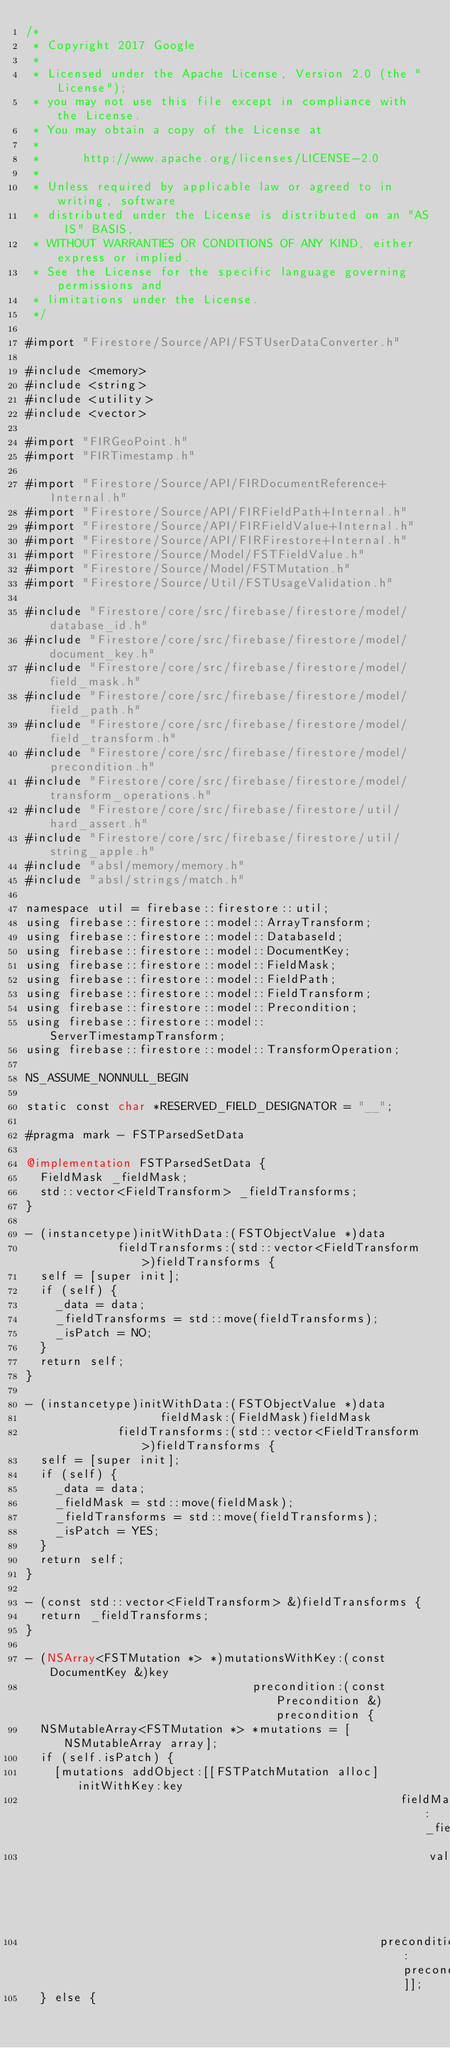Convert code to text. <code><loc_0><loc_0><loc_500><loc_500><_ObjectiveC_>/*
 * Copyright 2017 Google
 *
 * Licensed under the Apache License, Version 2.0 (the "License");
 * you may not use this file except in compliance with the License.
 * You may obtain a copy of the License at
 *
 *      http://www.apache.org/licenses/LICENSE-2.0
 *
 * Unless required by applicable law or agreed to in writing, software
 * distributed under the License is distributed on an "AS IS" BASIS,
 * WITHOUT WARRANTIES OR CONDITIONS OF ANY KIND, either express or implied.
 * See the License for the specific language governing permissions and
 * limitations under the License.
 */

#import "Firestore/Source/API/FSTUserDataConverter.h"

#include <memory>
#include <string>
#include <utility>
#include <vector>

#import "FIRGeoPoint.h"
#import "FIRTimestamp.h"

#import "Firestore/Source/API/FIRDocumentReference+Internal.h"
#import "Firestore/Source/API/FIRFieldPath+Internal.h"
#import "Firestore/Source/API/FIRFieldValue+Internal.h"
#import "Firestore/Source/API/FIRFirestore+Internal.h"
#import "Firestore/Source/Model/FSTFieldValue.h"
#import "Firestore/Source/Model/FSTMutation.h"
#import "Firestore/Source/Util/FSTUsageValidation.h"

#include "Firestore/core/src/firebase/firestore/model/database_id.h"
#include "Firestore/core/src/firebase/firestore/model/document_key.h"
#include "Firestore/core/src/firebase/firestore/model/field_mask.h"
#include "Firestore/core/src/firebase/firestore/model/field_path.h"
#include "Firestore/core/src/firebase/firestore/model/field_transform.h"
#include "Firestore/core/src/firebase/firestore/model/precondition.h"
#include "Firestore/core/src/firebase/firestore/model/transform_operations.h"
#include "Firestore/core/src/firebase/firestore/util/hard_assert.h"
#include "Firestore/core/src/firebase/firestore/util/string_apple.h"
#include "absl/memory/memory.h"
#include "absl/strings/match.h"

namespace util = firebase::firestore::util;
using firebase::firestore::model::ArrayTransform;
using firebase::firestore::model::DatabaseId;
using firebase::firestore::model::DocumentKey;
using firebase::firestore::model::FieldMask;
using firebase::firestore::model::FieldPath;
using firebase::firestore::model::FieldTransform;
using firebase::firestore::model::Precondition;
using firebase::firestore::model::ServerTimestampTransform;
using firebase::firestore::model::TransformOperation;

NS_ASSUME_NONNULL_BEGIN

static const char *RESERVED_FIELD_DESIGNATOR = "__";

#pragma mark - FSTParsedSetData

@implementation FSTParsedSetData {
  FieldMask _fieldMask;
  std::vector<FieldTransform> _fieldTransforms;
}

- (instancetype)initWithData:(FSTObjectValue *)data
             fieldTransforms:(std::vector<FieldTransform>)fieldTransforms {
  self = [super init];
  if (self) {
    _data = data;
    _fieldTransforms = std::move(fieldTransforms);
    _isPatch = NO;
  }
  return self;
}

- (instancetype)initWithData:(FSTObjectValue *)data
                   fieldMask:(FieldMask)fieldMask
             fieldTransforms:(std::vector<FieldTransform>)fieldTransforms {
  self = [super init];
  if (self) {
    _data = data;
    _fieldMask = std::move(fieldMask);
    _fieldTransforms = std::move(fieldTransforms);
    _isPatch = YES;
  }
  return self;
}

- (const std::vector<FieldTransform> &)fieldTransforms {
  return _fieldTransforms;
}

- (NSArray<FSTMutation *> *)mutationsWithKey:(const DocumentKey &)key
                                precondition:(const Precondition &)precondition {
  NSMutableArray<FSTMutation *> *mutations = [NSMutableArray array];
  if (self.isPatch) {
    [mutations addObject:[[FSTPatchMutation alloc] initWithKey:key
                                                     fieldMask:_fieldMask
                                                         value:self.data
                                                  precondition:precondition]];
  } else {</code> 